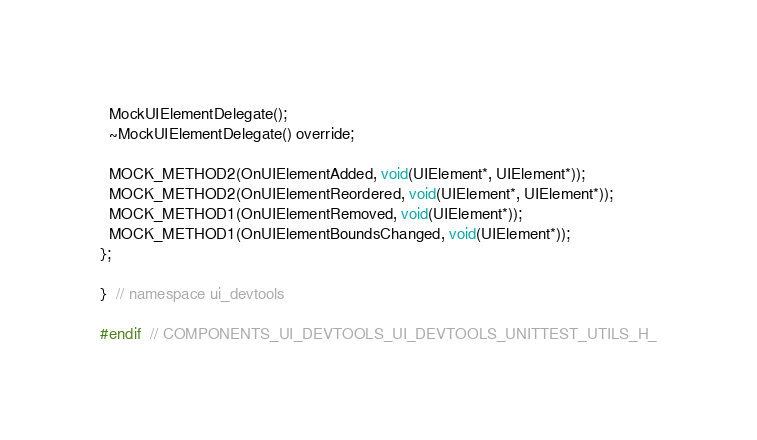<code> <loc_0><loc_0><loc_500><loc_500><_C_>  MockUIElementDelegate();
  ~MockUIElementDelegate() override;

  MOCK_METHOD2(OnUIElementAdded, void(UIElement*, UIElement*));
  MOCK_METHOD2(OnUIElementReordered, void(UIElement*, UIElement*));
  MOCK_METHOD1(OnUIElementRemoved, void(UIElement*));
  MOCK_METHOD1(OnUIElementBoundsChanged, void(UIElement*));
};

}  // namespace ui_devtools

#endif  // COMPONENTS_UI_DEVTOOLS_UI_DEVTOOLS_UNITTEST_UTILS_H_
</code> 